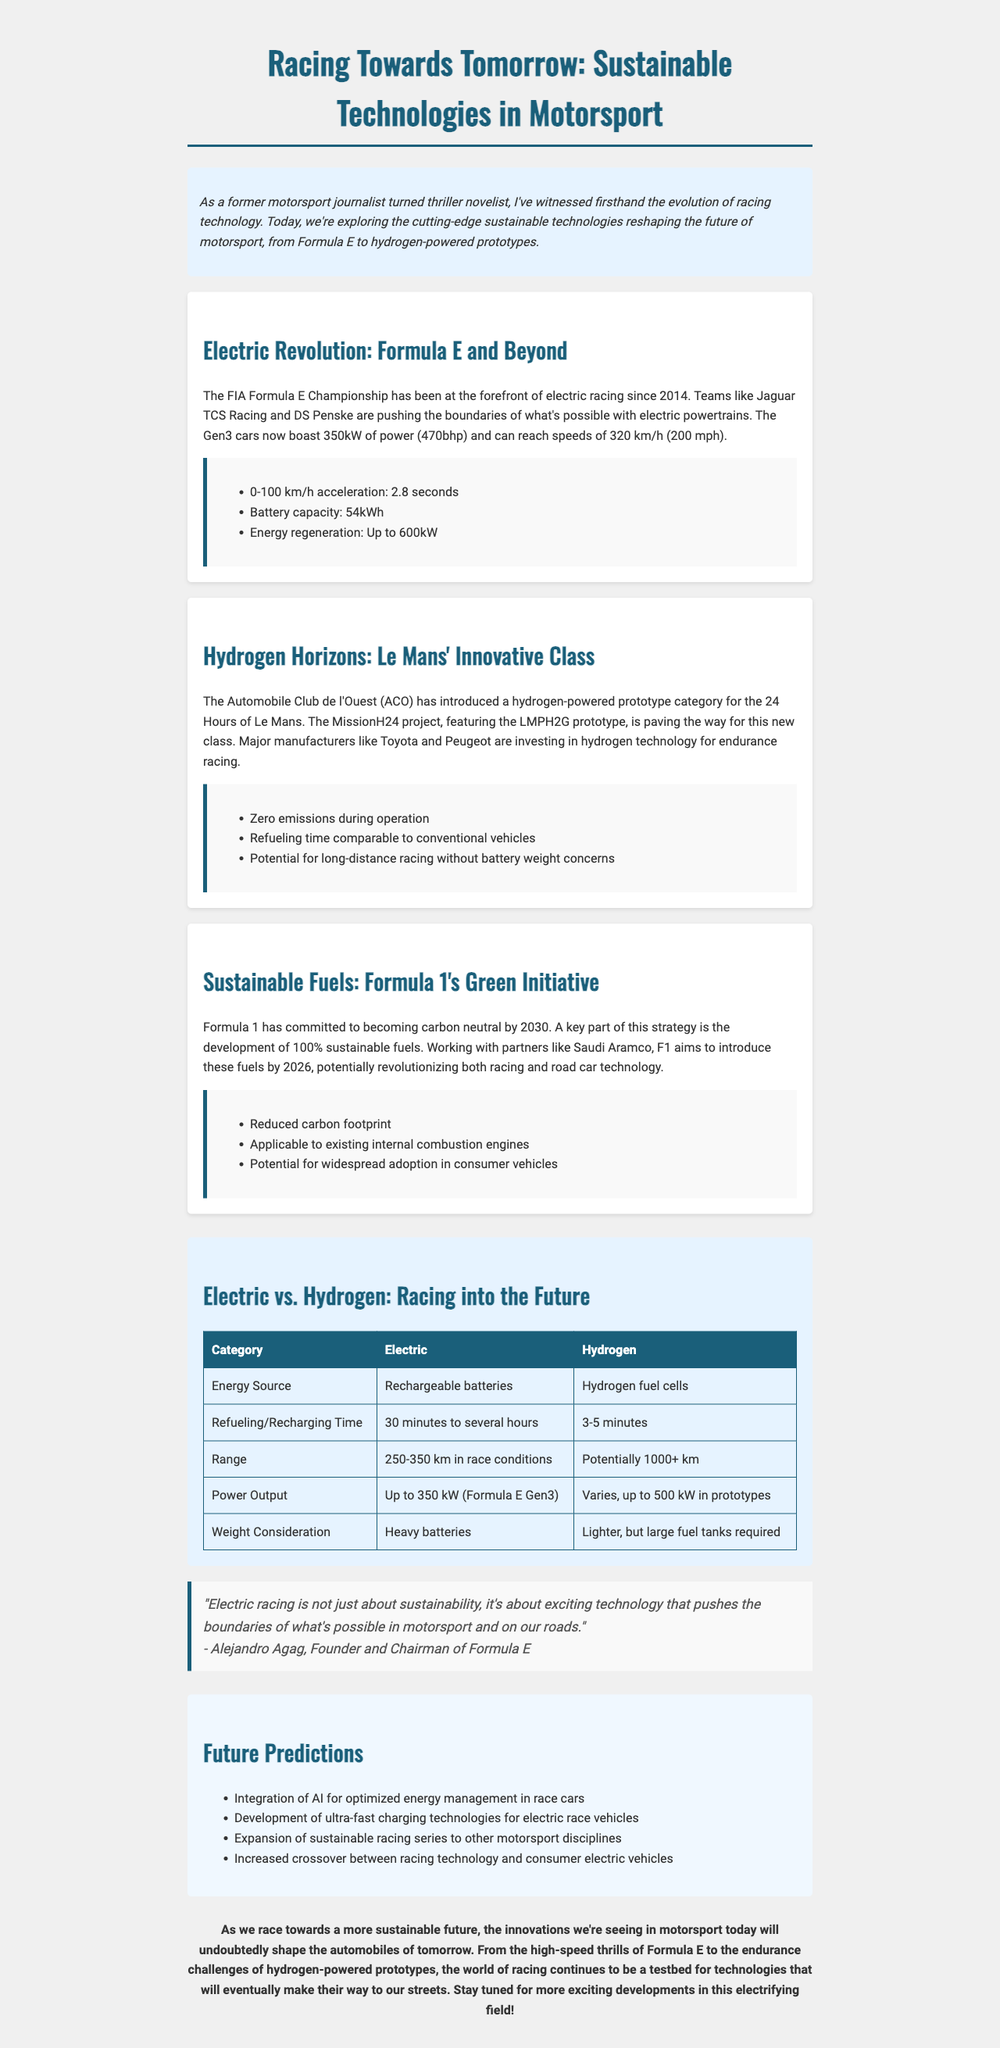what is the title of the newsletter? The title of the newsletter is provided in the data as "Racing Towards Tomorrow: Sustainable Technologies in Motorsport."
Answer: Racing Towards Tomorrow: Sustainable Technologies in Motorsport what is the main focus of the newsletter? The focus of the newsletter is on sustainable racing technologies reshaping motorsport, including electric and hydrogen-powered vehicles.
Answer: Sustainable racing technologies what is the power output of Formula E Gen3 cars? The document states that Formula E Gen3 cars have a power output of 350 kW.
Answer: 350 kW how long does it take to refuel a hydrogen vehicle? The document mentions that refueling hydrogen vehicles takes about 3 to 5 minutes.
Answer: 3 to 5 minutes who is the founder of Formula E? The document provides the name of the founder of Formula E as Alejandro Agag.
Answer: Alejandro Agag what is the battery capacity of Formula E cars? The battery capacity of Formula E cars is stated as 54 kWh.
Answer: 54 kWh what is Formula 1's carbon neutrality goal year? The document indicates Formula 1 aims to be carbon neutral by the year 2030.
Answer: 2030 which fuel technology has the potential for long-distance racing? The document mentions hydrogen technology as having the potential for long-distance racing without battery weight concerns.
Answer: Hydrogen technology what is the comparison point for the weight consideration between electric and hydrogen vehicles? The document states that electric vehicles have heavy batteries, while hydrogen vehicles require lighter tanks but are larger.
Answer: Heavy batteries vs. larger tanks 